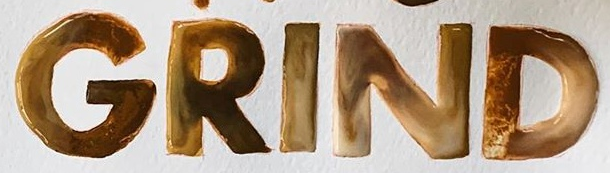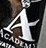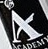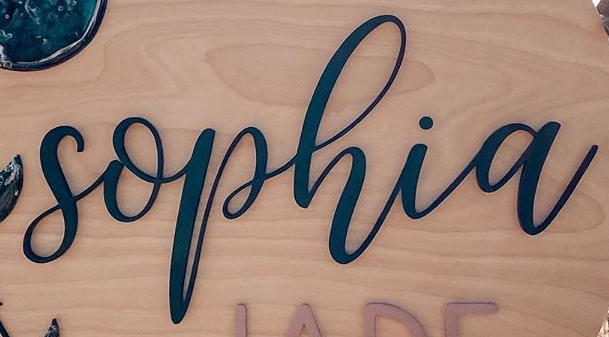What text is displayed in these images sequentially, separated by a semicolon? GRIND; A; A; sophia 